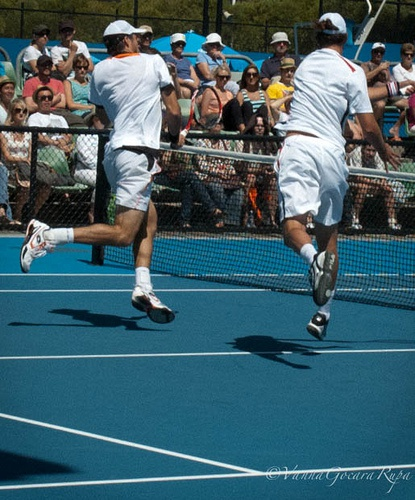Describe the objects in this image and their specific colors. I can see people in darkgreen, black, gray, darkgray, and lightgray tones, people in darkgreen, lightgray, black, darkgray, and gray tones, people in darkgreen, lightgray, black, darkgray, and gray tones, people in darkgreen, black, teal, gray, and darkgray tones, and people in darkgreen, black, gray, and maroon tones in this image. 